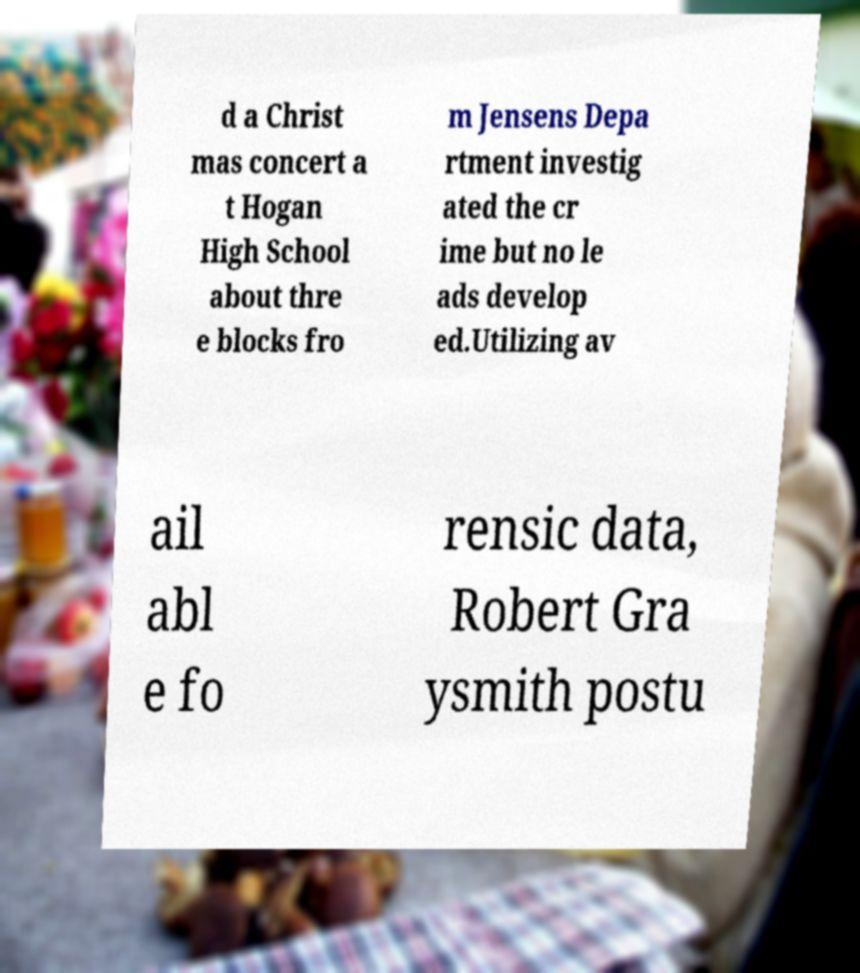There's text embedded in this image that I need extracted. Can you transcribe it verbatim? d a Christ mas concert a t Hogan High School about thre e blocks fro m Jensens Depa rtment investig ated the cr ime but no le ads develop ed.Utilizing av ail abl e fo rensic data, Robert Gra ysmith postu 